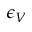Convert formula to latex. <formula><loc_0><loc_0><loc_500><loc_500>\epsilon _ { V }</formula> 